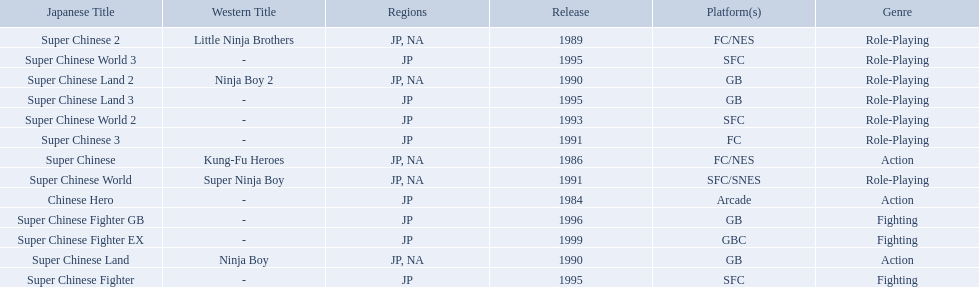What japanese titles were released in the north american (na) region? Super Chinese, Super Chinese 2, Super Chinese Land, Super Chinese Land 2, Super Chinese World. Of those, which one was released most recently? Super Chinese World. 